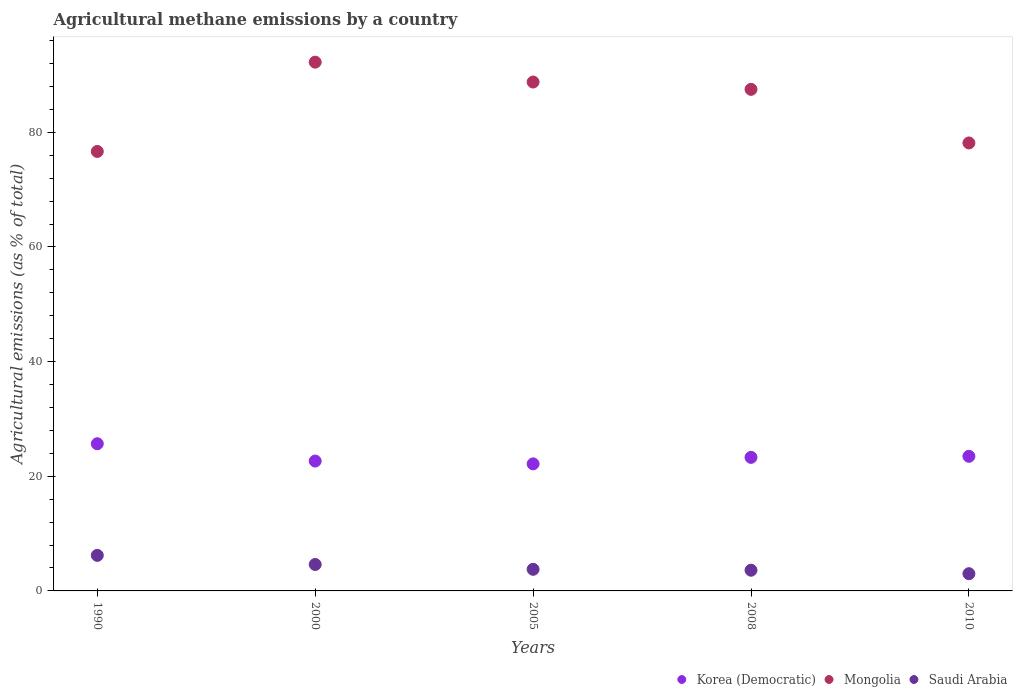How many different coloured dotlines are there?
Offer a very short reply. 3. What is the amount of agricultural methane emitted in Saudi Arabia in 2000?
Offer a terse response. 4.61. Across all years, what is the maximum amount of agricultural methane emitted in Saudi Arabia?
Keep it short and to the point. 6.2. Across all years, what is the minimum amount of agricultural methane emitted in Mongolia?
Your answer should be compact. 76.66. What is the total amount of agricultural methane emitted in Mongolia in the graph?
Make the answer very short. 423.3. What is the difference between the amount of agricultural methane emitted in Korea (Democratic) in 2000 and that in 2010?
Ensure brevity in your answer.  -0.83. What is the difference between the amount of agricultural methane emitted in Korea (Democratic) in 2000 and the amount of agricultural methane emitted in Mongolia in 2010?
Provide a succinct answer. -55.49. What is the average amount of agricultural methane emitted in Mongolia per year?
Offer a very short reply. 84.66. In the year 2005, what is the difference between the amount of agricultural methane emitted in Mongolia and amount of agricultural methane emitted in Korea (Democratic)?
Offer a terse response. 66.6. What is the ratio of the amount of agricultural methane emitted in Saudi Arabia in 2000 to that in 2010?
Your response must be concise. 1.54. What is the difference between the highest and the second highest amount of agricultural methane emitted in Korea (Democratic)?
Make the answer very short. 2.19. What is the difference between the highest and the lowest amount of agricultural methane emitted in Korea (Democratic)?
Your answer should be very brief. 3.51. Is the sum of the amount of agricultural methane emitted in Saudi Arabia in 2005 and 2010 greater than the maximum amount of agricultural methane emitted in Mongolia across all years?
Your answer should be compact. No. Is it the case that in every year, the sum of the amount of agricultural methane emitted in Korea (Democratic) and amount of agricultural methane emitted in Saudi Arabia  is greater than the amount of agricultural methane emitted in Mongolia?
Provide a short and direct response. No. Does the amount of agricultural methane emitted in Korea (Democratic) monotonically increase over the years?
Keep it short and to the point. No. Is the amount of agricultural methane emitted in Mongolia strictly less than the amount of agricultural methane emitted in Korea (Democratic) over the years?
Keep it short and to the point. No. How many dotlines are there?
Your answer should be very brief. 3. Does the graph contain grids?
Offer a very short reply. No. Where does the legend appear in the graph?
Make the answer very short. Bottom right. How are the legend labels stacked?
Your answer should be compact. Horizontal. What is the title of the graph?
Make the answer very short. Agricultural methane emissions by a country. What is the label or title of the Y-axis?
Your answer should be compact. Agricultural emissions (as % of total). What is the Agricultural emissions (as % of total) of Korea (Democratic) in 1990?
Offer a very short reply. 25.68. What is the Agricultural emissions (as % of total) of Mongolia in 1990?
Your answer should be very brief. 76.66. What is the Agricultural emissions (as % of total) of Saudi Arabia in 1990?
Provide a short and direct response. 6.2. What is the Agricultural emissions (as % of total) of Korea (Democratic) in 2000?
Give a very brief answer. 22.65. What is the Agricultural emissions (as % of total) in Mongolia in 2000?
Provide a succinct answer. 92.24. What is the Agricultural emissions (as % of total) in Saudi Arabia in 2000?
Your response must be concise. 4.61. What is the Agricultural emissions (as % of total) in Korea (Democratic) in 2005?
Make the answer very short. 22.16. What is the Agricultural emissions (as % of total) in Mongolia in 2005?
Your answer should be very brief. 88.77. What is the Agricultural emissions (as % of total) of Saudi Arabia in 2005?
Offer a terse response. 3.77. What is the Agricultural emissions (as % of total) in Korea (Democratic) in 2008?
Provide a succinct answer. 23.3. What is the Agricultural emissions (as % of total) in Mongolia in 2008?
Provide a succinct answer. 87.49. What is the Agricultural emissions (as % of total) of Saudi Arabia in 2008?
Offer a very short reply. 3.61. What is the Agricultural emissions (as % of total) of Korea (Democratic) in 2010?
Keep it short and to the point. 23.48. What is the Agricultural emissions (as % of total) of Mongolia in 2010?
Provide a succinct answer. 78.14. What is the Agricultural emissions (as % of total) in Saudi Arabia in 2010?
Provide a short and direct response. 3.01. Across all years, what is the maximum Agricultural emissions (as % of total) in Korea (Democratic)?
Your answer should be very brief. 25.68. Across all years, what is the maximum Agricultural emissions (as % of total) in Mongolia?
Your response must be concise. 92.24. Across all years, what is the maximum Agricultural emissions (as % of total) of Saudi Arabia?
Ensure brevity in your answer.  6.2. Across all years, what is the minimum Agricultural emissions (as % of total) in Korea (Democratic)?
Ensure brevity in your answer.  22.16. Across all years, what is the minimum Agricultural emissions (as % of total) in Mongolia?
Provide a short and direct response. 76.66. Across all years, what is the minimum Agricultural emissions (as % of total) in Saudi Arabia?
Your answer should be compact. 3.01. What is the total Agricultural emissions (as % of total) in Korea (Democratic) in the graph?
Keep it short and to the point. 117.27. What is the total Agricultural emissions (as % of total) of Mongolia in the graph?
Offer a very short reply. 423.3. What is the total Agricultural emissions (as % of total) of Saudi Arabia in the graph?
Keep it short and to the point. 21.2. What is the difference between the Agricultural emissions (as % of total) of Korea (Democratic) in 1990 and that in 2000?
Offer a terse response. 3.02. What is the difference between the Agricultural emissions (as % of total) in Mongolia in 1990 and that in 2000?
Provide a short and direct response. -15.58. What is the difference between the Agricultural emissions (as % of total) in Saudi Arabia in 1990 and that in 2000?
Make the answer very short. 1.59. What is the difference between the Agricultural emissions (as % of total) in Korea (Democratic) in 1990 and that in 2005?
Your answer should be compact. 3.51. What is the difference between the Agricultural emissions (as % of total) in Mongolia in 1990 and that in 2005?
Your answer should be compact. -12.11. What is the difference between the Agricultural emissions (as % of total) of Saudi Arabia in 1990 and that in 2005?
Keep it short and to the point. 2.43. What is the difference between the Agricultural emissions (as % of total) of Korea (Democratic) in 1990 and that in 2008?
Your answer should be very brief. 2.38. What is the difference between the Agricultural emissions (as % of total) of Mongolia in 1990 and that in 2008?
Offer a very short reply. -10.83. What is the difference between the Agricultural emissions (as % of total) in Saudi Arabia in 1990 and that in 2008?
Make the answer very short. 2.59. What is the difference between the Agricultural emissions (as % of total) in Korea (Democratic) in 1990 and that in 2010?
Provide a short and direct response. 2.19. What is the difference between the Agricultural emissions (as % of total) in Mongolia in 1990 and that in 2010?
Keep it short and to the point. -1.48. What is the difference between the Agricultural emissions (as % of total) of Saudi Arabia in 1990 and that in 2010?
Ensure brevity in your answer.  3.2. What is the difference between the Agricultural emissions (as % of total) of Korea (Democratic) in 2000 and that in 2005?
Give a very brief answer. 0.49. What is the difference between the Agricultural emissions (as % of total) of Mongolia in 2000 and that in 2005?
Your answer should be very brief. 3.47. What is the difference between the Agricultural emissions (as % of total) of Saudi Arabia in 2000 and that in 2005?
Your answer should be compact. 0.84. What is the difference between the Agricultural emissions (as % of total) in Korea (Democratic) in 2000 and that in 2008?
Give a very brief answer. -0.64. What is the difference between the Agricultural emissions (as % of total) of Mongolia in 2000 and that in 2008?
Make the answer very short. 4.74. What is the difference between the Agricultural emissions (as % of total) in Korea (Democratic) in 2000 and that in 2010?
Your response must be concise. -0.83. What is the difference between the Agricultural emissions (as % of total) in Mongolia in 2000 and that in 2010?
Your answer should be very brief. 14.1. What is the difference between the Agricultural emissions (as % of total) of Saudi Arabia in 2000 and that in 2010?
Make the answer very short. 1.61. What is the difference between the Agricultural emissions (as % of total) of Korea (Democratic) in 2005 and that in 2008?
Ensure brevity in your answer.  -1.13. What is the difference between the Agricultural emissions (as % of total) of Mongolia in 2005 and that in 2008?
Give a very brief answer. 1.28. What is the difference between the Agricultural emissions (as % of total) of Saudi Arabia in 2005 and that in 2008?
Your answer should be very brief. 0.16. What is the difference between the Agricultural emissions (as % of total) of Korea (Democratic) in 2005 and that in 2010?
Offer a terse response. -1.32. What is the difference between the Agricultural emissions (as % of total) in Mongolia in 2005 and that in 2010?
Your answer should be very brief. 10.63. What is the difference between the Agricultural emissions (as % of total) in Saudi Arabia in 2005 and that in 2010?
Your answer should be very brief. 0.76. What is the difference between the Agricultural emissions (as % of total) in Korea (Democratic) in 2008 and that in 2010?
Give a very brief answer. -0.18. What is the difference between the Agricultural emissions (as % of total) in Mongolia in 2008 and that in 2010?
Ensure brevity in your answer.  9.35. What is the difference between the Agricultural emissions (as % of total) of Saudi Arabia in 2008 and that in 2010?
Keep it short and to the point. 0.61. What is the difference between the Agricultural emissions (as % of total) of Korea (Democratic) in 1990 and the Agricultural emissions (as % of total) of Mongolia in 2000?
Your response must be concise. -66.56. What is the difference between the Agricultural emissions (as % of total) in Korea (Democratic) in 1990 and the Agricultural emissions (as % of total) in Saudi Arabia in 2000?
Give a very brief answer. 21.06. What is the difference between the Agricultural emissions (as % of total) of Mongolia in 1990 and the Agricultural emissions (as % of total) of Saudi Arabia in 2000?
Ensure brevity in your answer.  72.05. What is the difference between the Agricultural emissions (as % of total) in Korea (Democratic) in 1990 and the Agricultural emissions (as % of total) in Mongolia in 2005?
Make the answer very short. -63.09. What is the difference between the Agricultural emissions (as % of total) in Korea (Democratic) in 1990 and the Agricultural emissions (as % of total) in Saudi Arabia in 2005?
Provide a short and direct response. 21.91. What is the difference between the Agricultural emissions (as % of total) in Mongolia in 1990 and the Agricultural emissions (as % of total) in Saudi Arabia in 2005?
Give a very brief answer. 72.89. What is the difference between the Agricultural emissions (as % of total) of Korea (Democratic) in 1990 and the Agricultural emissions (as % of total) of Mongolia in 2008?
Your answer should be compact. -61.82. What is the difference between the Agricultural emissions (as % of total) of Korea (Democratic) in 1990 and the Agricultural emissions (as % of total) of Saudi Arabia in 2008?
Give a very brief answer. 22.06. What is the difference between the Agricultural emissions (as % of total) of Mongolia in 1990 and the Agricultural emissions (as % of total) of Saudi Arabia in 2008?
Offer a terse response. 73.05. What is the difference between the Agricultural emissions (as % of total) of Korea (Democratic) in 1990 and the Agricultural emissions (as % of total) of Mongolia in 2010?
Keep it short and to the point. -52.47. What is the difference between the Agricultural emissions (as % of total) in Korea (Democratic) in 1990 and the Agricultural emissions (as % of total) in Saudi Arabia in 2010?
Offer a terse response. 22.67. What is the difference between the Agricultural emissions (as % of total) of Mongolia in 1990 and the Agricultural emissions (as % of total) of Saudi Arabia in 2010?
Your response must be concise. 73.65. What is the difference between the Agricultural emissions (as % of total) in Korea (Democratic) in 2000 and the Agricultural emissions (as % of total) in Mongolia in 2005?
Offer a terse response. -66.12. What is the difference between the Agricultural emissions (as % of total) of Korea (Democratic) in 2000 and the Agricultural emissions (as % of total) of Saudi Arabia in 2005?
Offer a terse response. 18.88. What is the difference between the Agricultural emissions (as % of total) of Mongolia in 2000 and the Agricultural emissions (as % of total) of Saudi Arabia in 2005?
Your response must be concise. 88.47. What is the difference between the Agricultural emissions (as % of total) of Korea (Democratic) in 2000 and the Agricultural emissions (as % of total) of Mongolia in 2008?
Your answer should be very brief. -64.84. What is the difference between the Agricultural emissions (as % of total) in Korea (Democratic) in 2000 and the Agricultural emissions (as % of total) in Saudi Arabia in 2008?
Offer a terse response. 19.04. What is the difference between the Agricultural emissions (as % of total) in Mongolia in 2000 and the Agricultural emissions (as % of total) in Saudi Arabia in 2008?
Keep it short and to the point. 88.62. What is the difference between the Agricultural emissions (as % of total) of Korea (Democratic) in 2000 and the Agricultural emissions (as % of total) of Mongolia in 2010?
Keep it short and to the point. -55.49. What is the difference between the Agricultural emissions (as % of total) of Korea (Democratic) in 2000 and the Agricultural emissions (as % of total) of Saudi Arabia in 2010?
Provide a short and direct response. 19.65. What is the difference between the Agricultural emissions (as % of total) in Mongolia in 2000 and the Agricultural emissions (as % of total) in Saudi Arabia in 2010?
Your answer should be compact. 89.23. What is the difference between the Agricultural emissions (as % of total) in Korea (Democratic) in 2005 and the Agricultural emissions (as % of total) in Mongolia in 2008?
Provide a succinct answer. -65.33. What is the difference between the Agricultural emissions (as % of total) in Korea (Democratic) in 2005 and the Agricultural emissions (as % of total) in Saudi Arabia in 2008?
Ensure brevity in your answer.  18.55. What is the difference between the Agricultural emissions (as % of total) in Mongolia in 2005 and the Agricultural emissions (as % of total) in Saudi Arabia in 2008?
Offer a very short reply. 85.16. What is the difference between the Agricultural emissions (as % of total) in Korea (Democratic) in 2005 and the Agricultural emissions (as % of total) in Mongolia in 2010?
Your response must be concise. -55.98. What is the difference between the Agricultural emissions (as % of total) of Korea (Democratic) in 2005 and the Agricultural emissions (as % of total) of Saudi Arabia in 2010?
Your answer should be very brief. 19.16. What is the difference between the Agricultural emissions (as % of total) of Mongolia in 2005 and the Agricultural emissions (as % of total) of Saudi Arabia in 2010?
Provide a short and direct response. 85.76. What is the difference between the Agricultural emissions (as % of total) of Korea (Democratic) in 2008 and the Agricultural emissions (as % of total) of Mongolia in 2010?
Provide a succinct answer. -54.84. What is the difference between the Agricultural emissions (as % of total) of Korea (Democratic) in 2008 and the Agricultural emissions (as % of total) of Saudi Arabia in 2010?
Your answer should be compact. 20.29. What is the difference between the Agricultural emissions (as % of total) in Mongolia in 2008 and the Agricultural emissions (as % of total) in Saudi Arabia in 2010?
Make the answer very short. 84.49. What is the average Agricultural emissions (as % of total) in Korea (Democratic) per year?
Your answer should be very brief. 23.45. What is the average Agricultural emissions (as % of total) of Mongolia per year?
Give a very brief answer. 84.66. What is the average Agricultural emissions (as % of total) of Saudi Arabia per year?
Keep it short and to the point. 4.24. In the year 1990, what is the difference between the Agricultural emissions (as % of total) in Korea (Democratic) and Agricultural emissions (as % of total) in Mongolia?
Offer a terse response. -50.98. In the year 1990, what is the difference between the Agricultural emissions (as % of total) of Korea (Democratic) and Agricultural emissions (as % of total) of Saudi Arabia?
Keep it short and to the point. 19.47. In the year 1990, what is the difference between the Agricultural emissions (as % of total) of Mongolia and Agricultural emissions (as % of total) of Saudi Arabia?
Offer a terse response. 70.46. In the year 2000, what is the difference between the Agricultural emissions (as % of total) in Korea (Democratic) and Agricultural emissions (as % of total) in Mongolia?
Ensure brevity in your answer.  -69.58. In the year 2000, what is the difference between the Agricultural emissions (as % of total) in Korea (Democratic) and Agricultural emissions (as % of total) in Saudi Arabia?
Offer a very short reply. 18.04. In the year 2000, what is the difference between the Agricultural emissions (as % of total) in Mongolia and Agricultural emissions (as % of total) in Saudi Arabia?
Provide a short and direct response. 87.62. In the year 2005, what is the difference between the Agricultural emissions (as % of total) in Korea (Democratic) and Agricultural emissions (as % of total) in Mongolia?
Your response must be concise. -66.6. In the year 2005, what is the difference between the Agricultural emissions (as % of total) of Korea (Democratic) and Agricultural emissions (as % of total) of Saudi Arabia?
Keep it short and to the point. 18.39. In the year 2005, what is the difference between the Agricultural emissions (as % of total) of Mongolia and Agricultural emissions (as % of total) of Saudi Arabia?
Keep it short and to the point. 85. In the year 2008, what is the difference between the Agricultural emissions (as % of total) of Korea (Democratic) and Agricultural emissions (as % of total) of Mongolia?
Offer a very short reply. -64.2. In the year 2008, what is the difference between the Agricultural emissions (as % of total) in Korea (Democratic) and Agricultural emissions (as % of total) in Saudi Arabia?
Offer a very short reply. 19.69. In the year 2008, what is the difference between the Agricultural emissions (as % of total) of Mongolia and Agricultural emissions (as % of total) of Saudi Arabia?
Your answer should be compact. 83.88. In the year 2010, what is the difference between the Agricultural emissions (as % of total) in Korea (Democratic) and Agricultural emissions (as % of total) in Mongolia?
Your response must be concise. -54.66. In the year 2010, what is the difference between the Agricultural emissions (as % of total) of Korea (Democratic) and Agricultural emissions (as % of total) of Saudi Arabia?
Offer a terse response. 20.48. In the year 2010, what is the difference between the Agricultural emissions (as % of total) in Mongolia and Agricultural emissions (as % of total) in Saudi Arabia?
Offer a terse response. 75.14. What is the ratio of the Agricultural emissions (as % of total) of Korea (Democratic) in 1990 to that in 2000?
Give a very brief answer. 1.13. What is the ratio of the Agricultural emissions (as % of total) of Mongolia in 1990 to that in 2000?
Provide a short and direct response. 0.83. What is the ratio of the Agricultural emissions (as % of total) in Saudi Arabia in 1990 to that in 2000?
Your answer should be compact. 1.34. What is the ratio of the Agricultural emissions (as % of total) of Korea (Democratic) in 1990 to that in 2005?
Keep it short and to the point. 1.16. What is the ratio of the Agricultural emissions (as % of total) in Mongolia in 1990 to that in 2005?
Provide a short and direct response. 0.86. What is the ratio of the Agricultural emissions (as % of total) in Saudi Arabia in 1990 to that in 2005?
Give a very brief answer. 1.65. What is the ratio of the Agricultural emissions (as % of total) in Korea (Democratic) in 1990 to that in 2008?
Your answer should be compact. 1.1. What is the ratio of the Agricultural emissions (as % of total) in Mongolia in 1990 to that in 2008?
Your answer should be compact. 0.88. What is the ratio of the Agricultural emissions (as % of total) in Saudi Arabia in 1990 to that in 2008?
Provide a succinct answer. 1.72. What is the ratio of the Agricultural emissions (as % of total) in Korea (Democratic) in 1990 to that in 2010?
Provide a succinct answer. 1.09. What is the ratio of the Agricultural emissions (as % of total) of Mongolia in 1990 to that in 2010?
Ensure brevity in your answer.  0.98. What is the ratio of the Agricultural emissions (as % of total) of Saudi Arabia in 1990 to that in 2010?
Provide a succinct answer. 2.06. What is the ratio of the Agricultural emissions (as % of total) of Korea (Democratic) in 2000 to that in 2005?
Your answer should be compact. 1.02. What is the ratio of the Agricultural emissions (as % of total) in Mongolia in 2000 to that in 2005?
Make the answer very short. 1.04. What is the ratio of the Agricultural emissions (as % of total) in Saudi Arabia in 2000 to that in 2005?
Your answer should be very brief. 1.22. What is the ratio of the Agricultural emissions (as % of total) in Korea (Democratic) in 2000 to that in 2008?
Provide a short and direct response. 0.97. What is the ratio of the Agricultural emissions (as % of total) of Mongolia in 2000 to that in 2008?
Make the answer very short. 1.05. What is the ratio of the Agricultural emissions (as % of total) in Saudi Arabia in 2000 to that in 2008?
Provide a short and direct response. 1.28. What is the ratio of the Agricultural emissions (as % of total) of Korea (Democratic) in 2000 to that in 2010?
Ensure brevity in your answer.  0.96. What is the ratio of the Agricultural emissions (as % of total) in Mongolia in 2000 to that in 2010?
Ensure brevity in your answer.  1.18. What is the ratio of the Agricultural emissions (as % of total) of Saudi Arabia in 2000 to that in 2010?
Offer a terse response. 1.54. What is the ratio of the Agricultural emissions (as % of total) of Korea (Democratic) in 2005 to that in 2008?
Make the answer very short. 0.95. What is the ratio of the Agricultural emissions (as % of total) in Mongolia in 2005 to that in 2008?
Offer a very short reply. 1.01. What is the ratio of the Agricultural emissions (as % of total) of Saudi Arabia in 2005 to that in 2008?
Your answer should be very brief. 1.04. What is the ratio of the Agricultural emissions (as % of total) in Korea (Democratic) in 2005 to that in 2010?
Provide a succinct answer. 0.94. What is the ratio of the Agricultural emissions (as % of total) in Mongolia in 2005 to that in 2010?
Provide a short and direct response. 1.14. What is the ratio of the Agricultural emissions (as % of total) in Saudi Arabia in 2005 to that in 2010?
Your answer should be compact. 1.25. What is the ratio of the Agricultural emissions (as % of total) in Korea (Democratic) in 2008 to that in 2010?
Your response must be concise. 0.99. What is the ratio of the Agricultural emissions (as % of total) in Mongolia in 2008 to that in 2010?
Give a very brief answer. 1.12. What is the ratio of the Agricultural emissions (as % of total) in Saudi Arabia in 2008 to that in 2010?
Your answer should be very brief. 1.2. What is the difference between the highest and the second highest Agricultural emissions (as % of total) of Korea (Democratic)?
Provide a short and direct response. 2.19. What is the difference between the highest and the second highest Agricultural emissions (as % of total) of Mongolia?
Your response must be concise. 3.47. What is the difference between the highest and the second highest Agricultural emissions (as % of total) of Saudi Arabia?
Provide a succinct answer. 1.59. What is the difference between the highest and the lowest Agricultural emissions (as % of total) of Korea (Democratic)?
Make the answer very short. 3.51. What is the difference between the highest and the lowest Agricultural emissions (as % of total) in Mongolia?
Provide a short and direct response. 15.58. What is the difference between the highest and the lowest Agricultural emissions (as % of total) in Saudi Arabia?
Your answer should be compact. 3.2. 